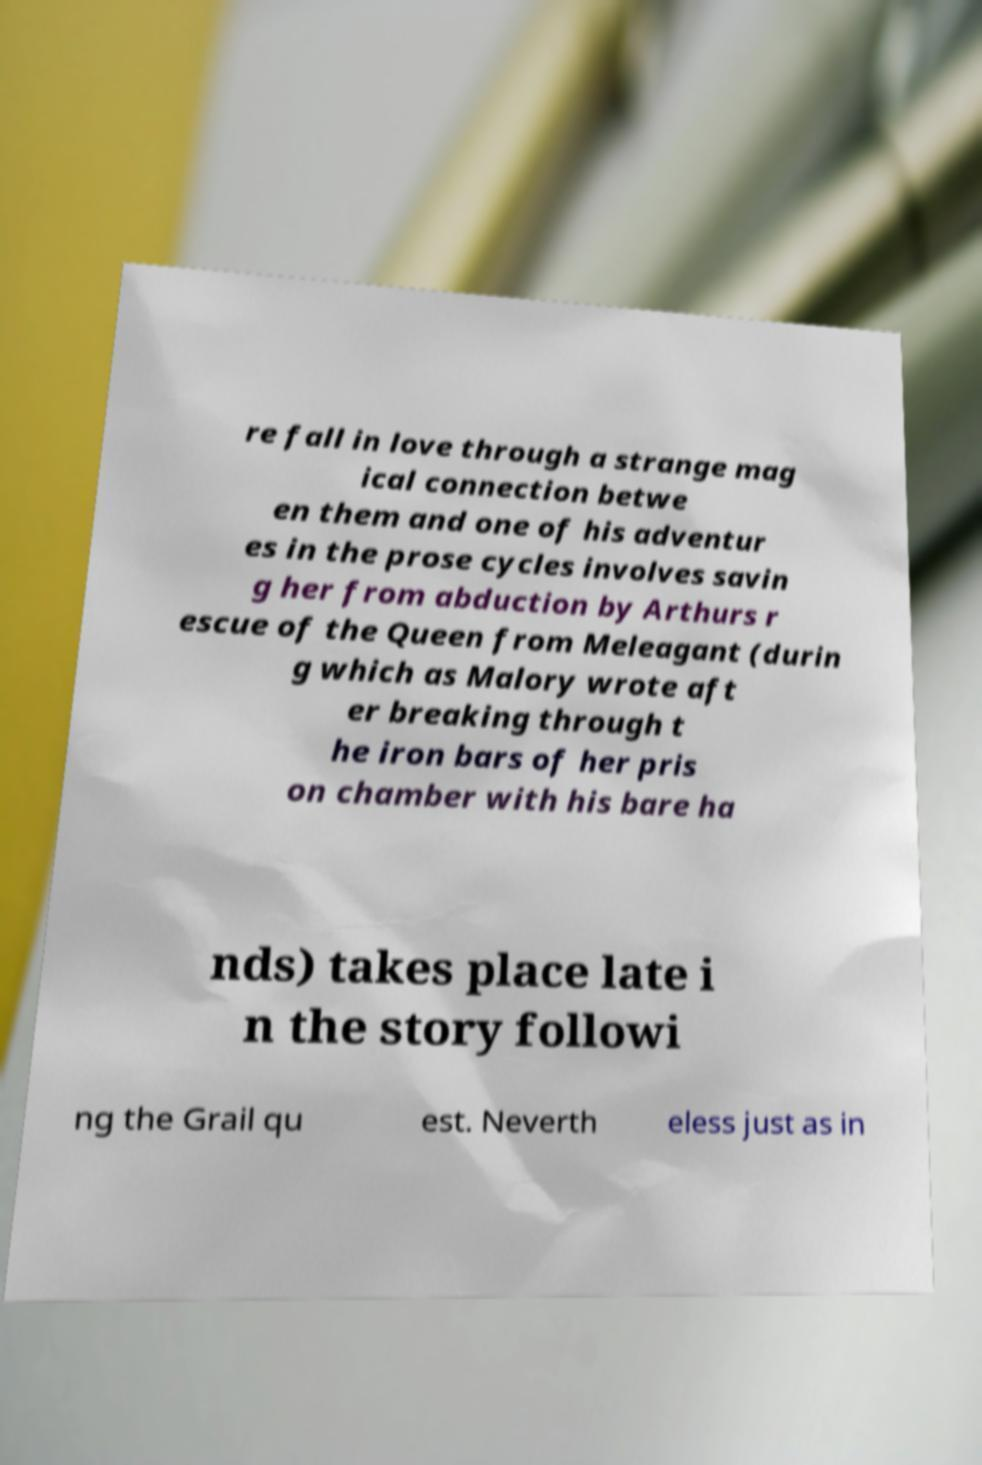Please read and relay the text visible in this image. What does it say? re fall in love through a strange mag ical connection betwe en them and one of his adventur es in the prose cycles involves savin g her from abduction by Arthurs r escue of the Queen from Meleagant (durin g which as Malory wrote aft er breaking through t he iron bars of her pris on chamber with his bare ha nds) takes place late i n the story followi ng the Grail qu est. Neverth eless just as in 